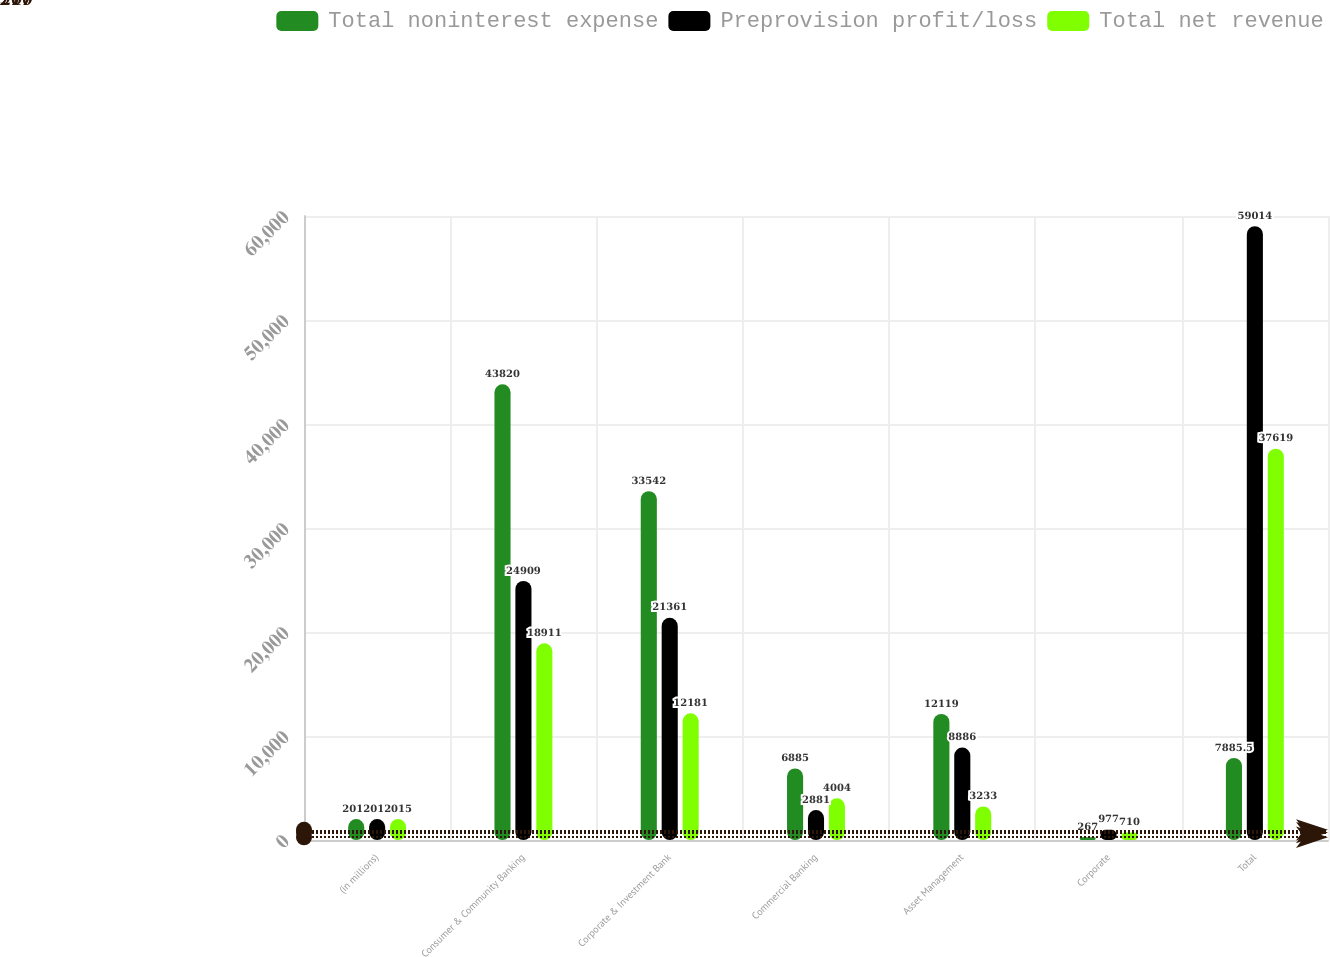<chart> <loc_0><loc_0><loc_500><loc_500><stacked_bar_chart><ecel><fcel>(in millions)<fcel>Consumer & Community Banking<fcel>Corporate & Investment Bank<fcel>Commercial Banking<fcel>Asset Management<fcel>Corporate<fcel>Total<nl><fcel>Total noninterest expense<fcel>2015<fcel>43820<fcel>33542<fcel>6885<fcel>12119<fcel>267<fcel>7885.5<nl><fcel>Preprovision profit/loss<fcel>2015<fcel>24909<fcel>21361<fcel>2881<fcel>8886<fcel>977<fcel>59014<nl><fcel>Total net revenue<fcel>2015<fcel>18911<fcel>12181<fcel>4004<fcel>3233<fcel>710<fcel>37619<nl></chart> 